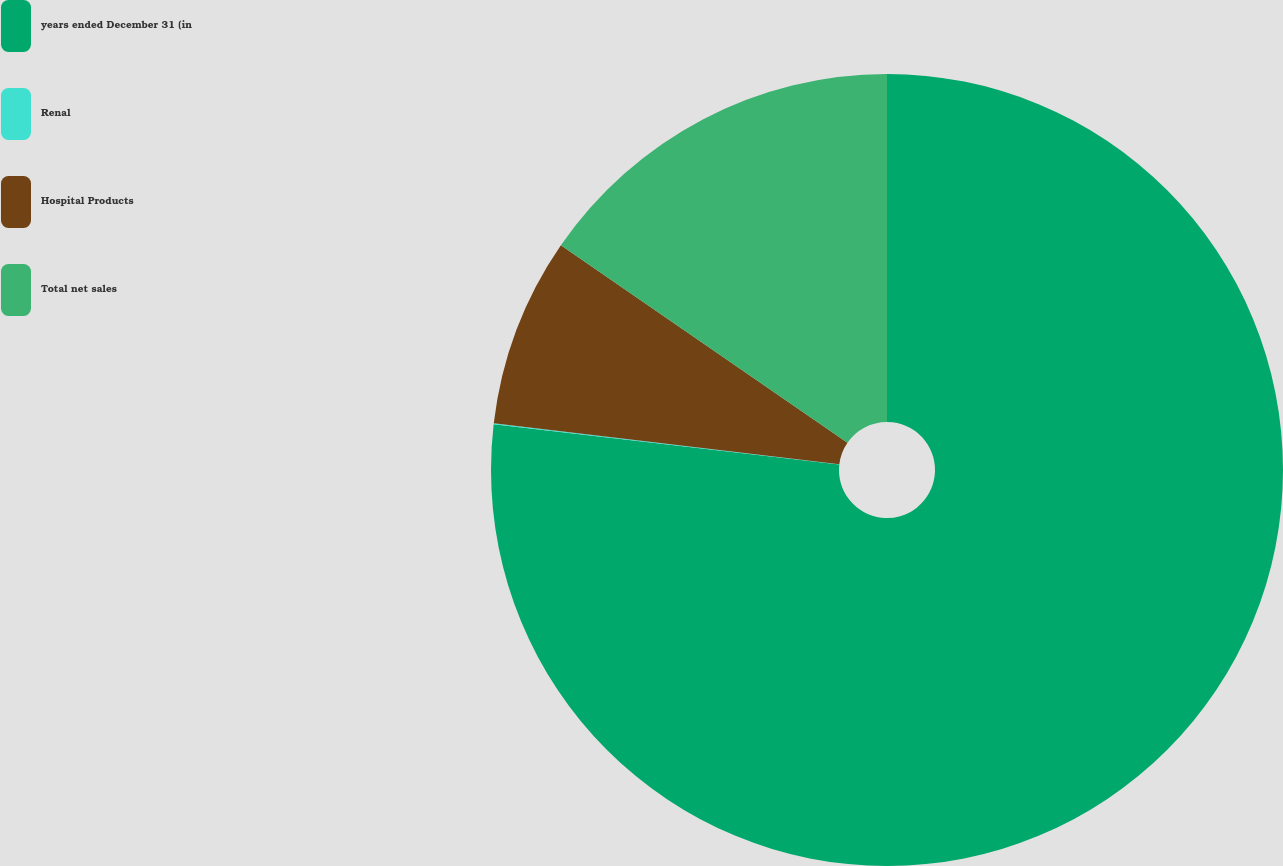Convert chart. <chart><loc_0><loc_0><loc_500><loc_500><pie_chart><fcel>years ended December 31 (in<fcel>Renal<fcel>Hospital Products<fcel>Total net sales<nl><fcel>76.84%<fcel>0.04%<fcel>7.72%<fcel>15.4%<nl></chart> 